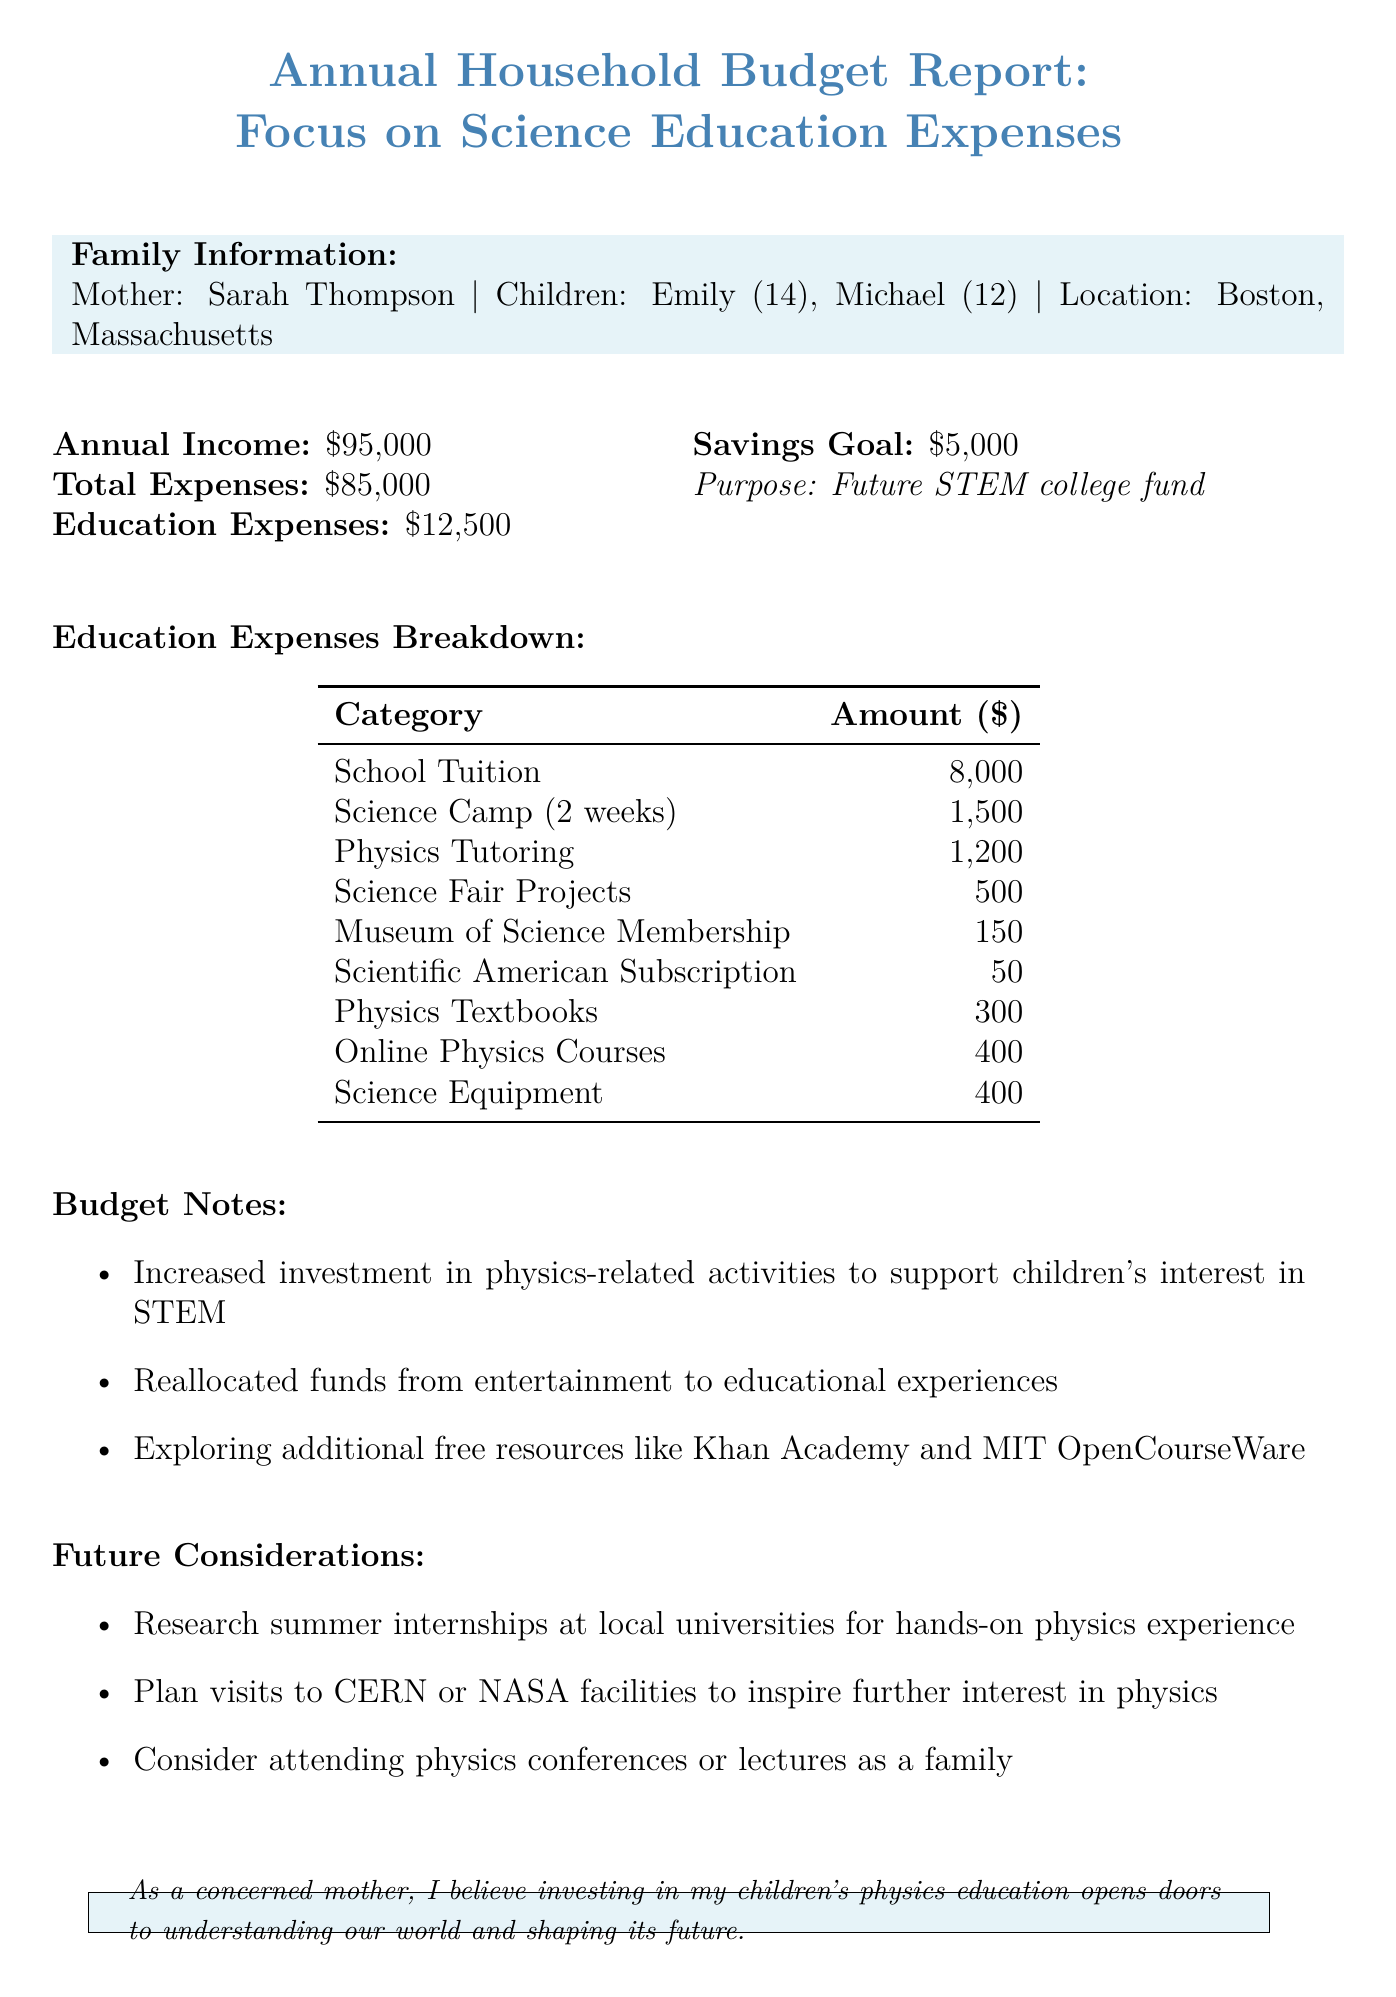What is the total annual income? The total annual income is listed in the document, which states the income amount as $95000.
Answer: $95000 How much is allocated for science camp? The document specifies the amount allocated for science camp as part of the education expenses, which is $1500.
Answer: $1500 What is the goal for savings? The document outlines the savings goal for the household, indicating that it is $5000.
Answer: $5000 Which educational expense has the highest allocation? The document shows the breakdown of education expenses, with school tuition being the highest at $8000.
Answer: School Tuition How much is spent on Physics Tutoring? The document includes a specific amount for Physics Tutoring, which is stated as $1200.
Answer: $1200 What are the budget notes suggesting about funding? The budget notes suggest reallocating funds, particularly moving funds from entertainment to educational experiences.
Answer: Reallocated funds What future consideration involves hands-on experience? The future considerations mention researching summer internships for hands-on physics experience.
Answer: Summer internships Who are the children in the Thompson family? The document lists the children’s names and ages as Emily (14) and Michael (12).
Answer: Emily (14), Michael (12) What is the purpose of the savings goal? In the document, the savings goal is outlined for a specific future purpose, which is for the future STEM college fund.
Answer: Future STEM college fund 